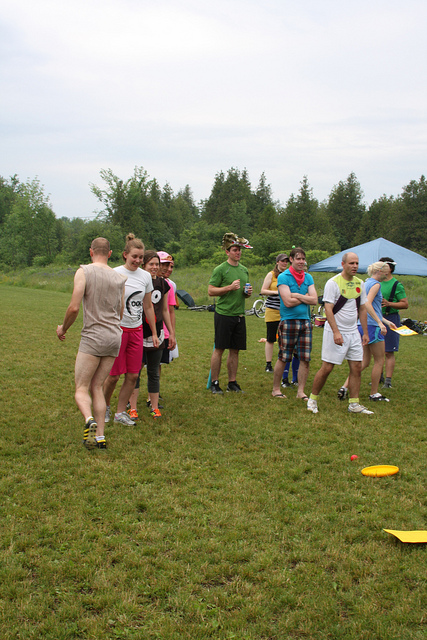What kind of event do you think is happening in this image? It looks like the group is participating in an outdoor recreational event, possibly a friendly game of frisbee or a casual sports day. Their sporty attire and the presence of frisbees on the ground suggest it's something fun and active, possibly organized in a relaxed, social environment like a family picnic or a community gathering. The participants look ready for a fun time! Can you describe the weather and surroundings based on the image? The weather seems mild and overcast, as indicated by the cloudy sky visible in the background. The setting is a grassy field bordered by trees, providing a lush, green backdrop. The tent pitched nearby suggests it's an organized event with areas for resting or gathering supplies. Overall, the environment adds to the laid-back and communal feel of the event. 